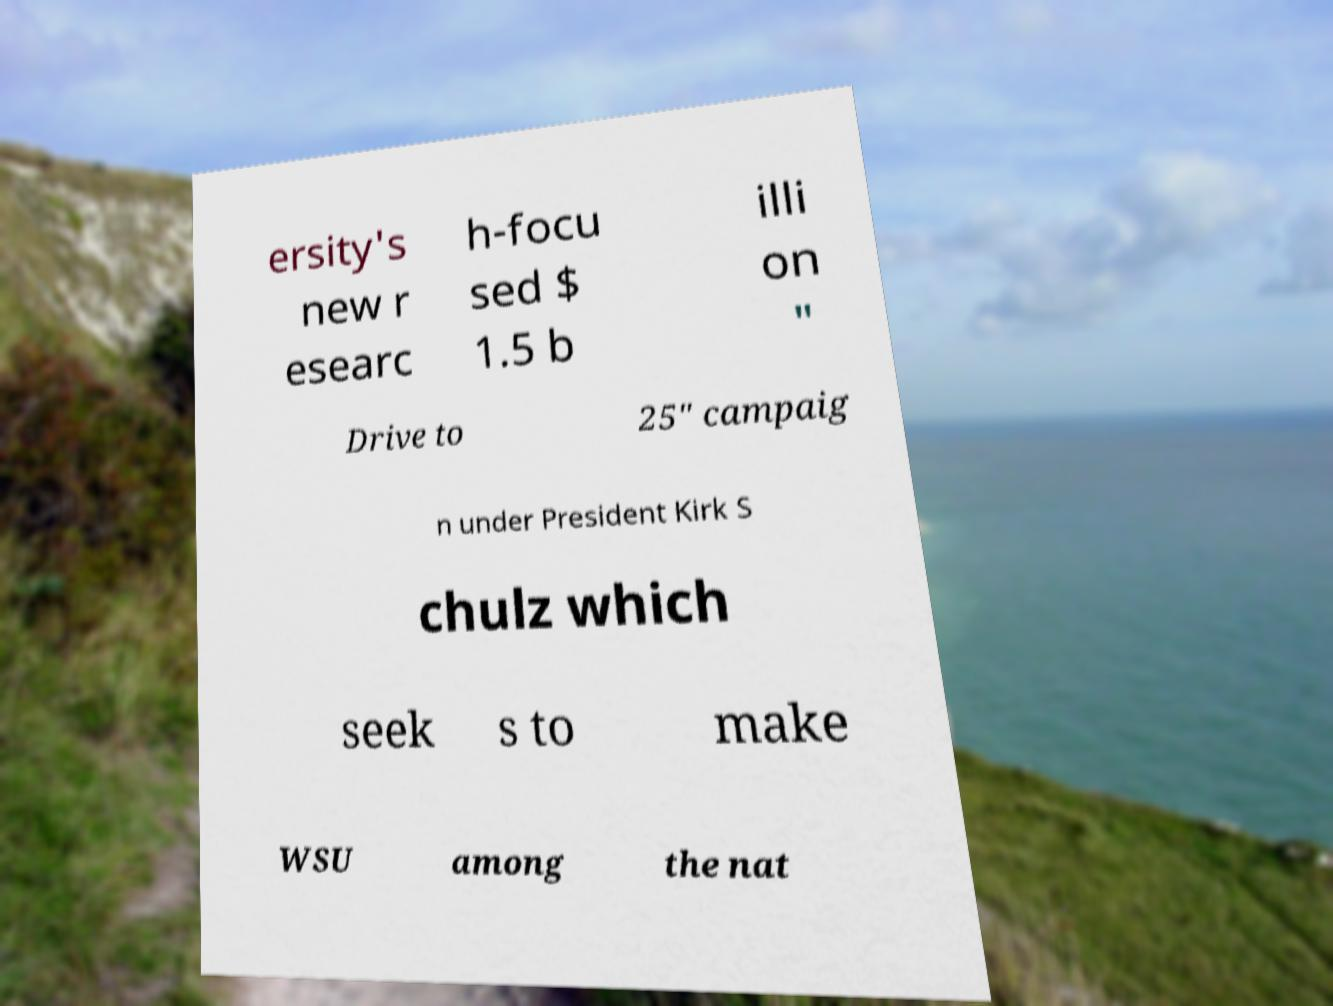Could you extract and type out the text from this image? ersity's new r esearc h-focu sed $ 1.5 b illi on " Drive to 25" campaig n under President Kirk S chulz which seek s to make WSU among the nat 